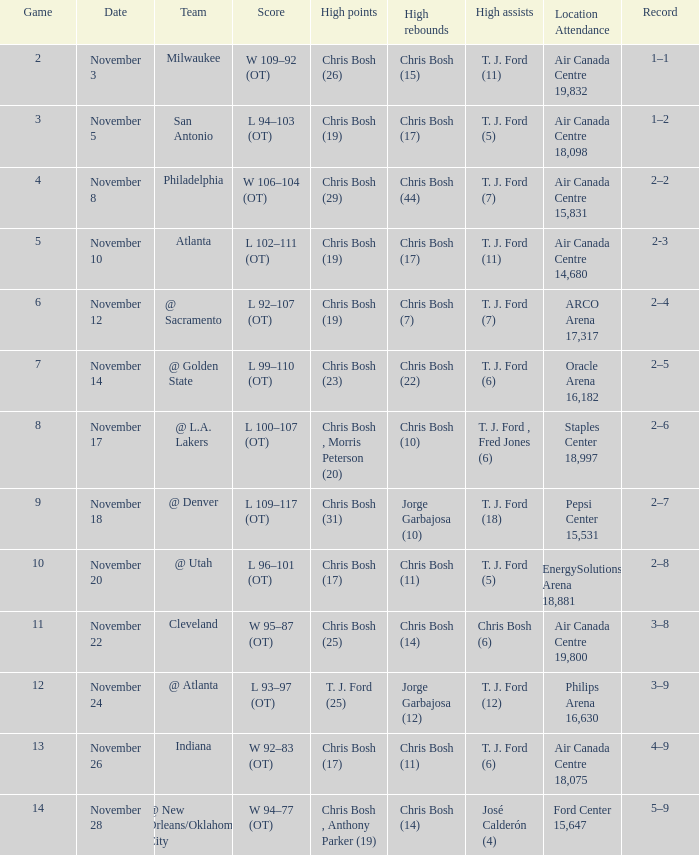In game 4, who had the highest point score? Chris Bosh (29). 